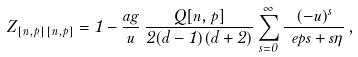Convert formula to latex. <formula><loc_0><loc_0><loc_500><loc_500>Z _ { [ n , p ] \, [ n , p ] } = 1 - \frac { a g } { u } \, \frac { Q [ n , p ] } { 2 ( d - 1 ) ( d + 2 ) } \sum ^ { \infty } _ { s = 0 } \frac { ( - u ) ^ { s } } { \ e p s + s \eta } \, ,</formula> 